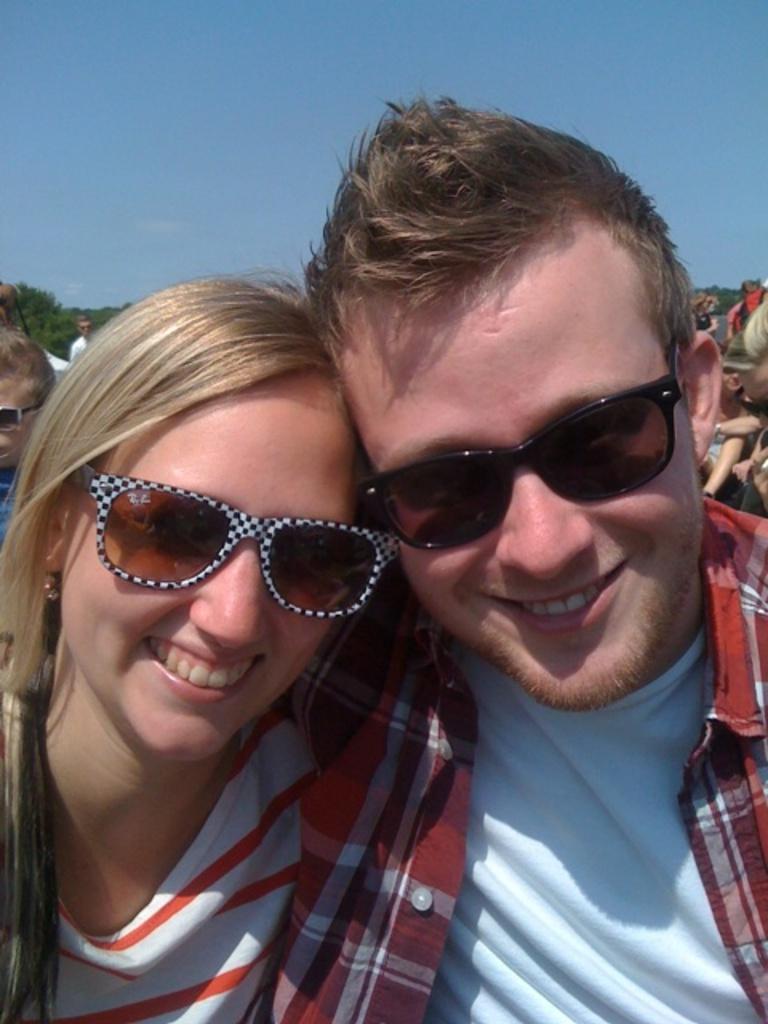In one or two sentences, can you explain what this image depicts? In this image I can see two persons, the person at right wearing red and white shirt, and the person at left wearing white and orange shirt. Background I can see few other persons, trees in green color, sky in blue color. 